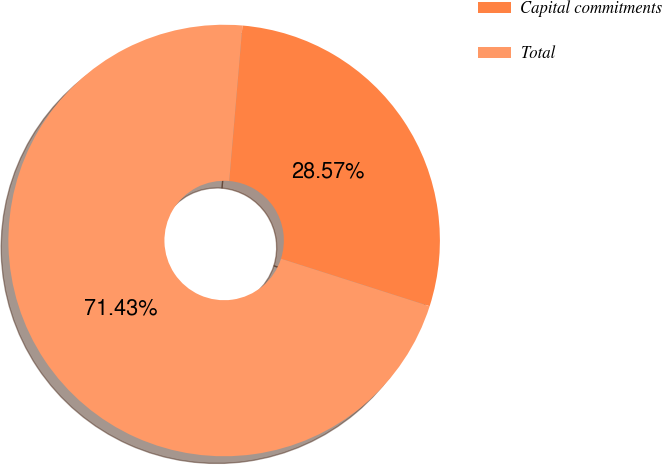Convert chart. <chart><loc_0><loc_0><loc_500><loc_500><pie_chart><fcel>Capital commitments<fcel>Total<nl><fcel>28.57%<fcel>71.43%<nl></chart> 